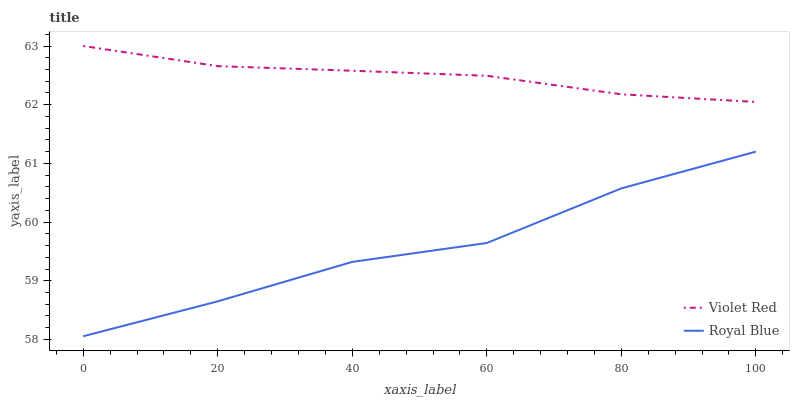Does Royal Blue have the minimum area under the curve?
Answer yes or no. Yes. Does Violet Red have the maximum area under the curve?
Answer yes or no. Yes. Does Violet Red have the minimum area under the curve?
Answer yes or no. No. Is Violet Red the smoothest?
Answer yes or no. Yes. Is Royal Blue the roughest?
Answer yes or no. Yes. Is Violet Red the roughest?
Answer yes or no. No. Does Royal Blue have the lowest value?
Answer yes or no. Yes. Does Violet Red have the lowest value?
Answer yes or no. No. Does Violet Red have the highest value?
Answer yes or no. Yes. Is Royal Blue less than Violet Red?
Answer yes or no. Yes. Is Violet Red greater than Royal Blue?
Answer yes or no. Yes. Does Royal Blue intersect Violet Red?
Answer yes or no. No. 